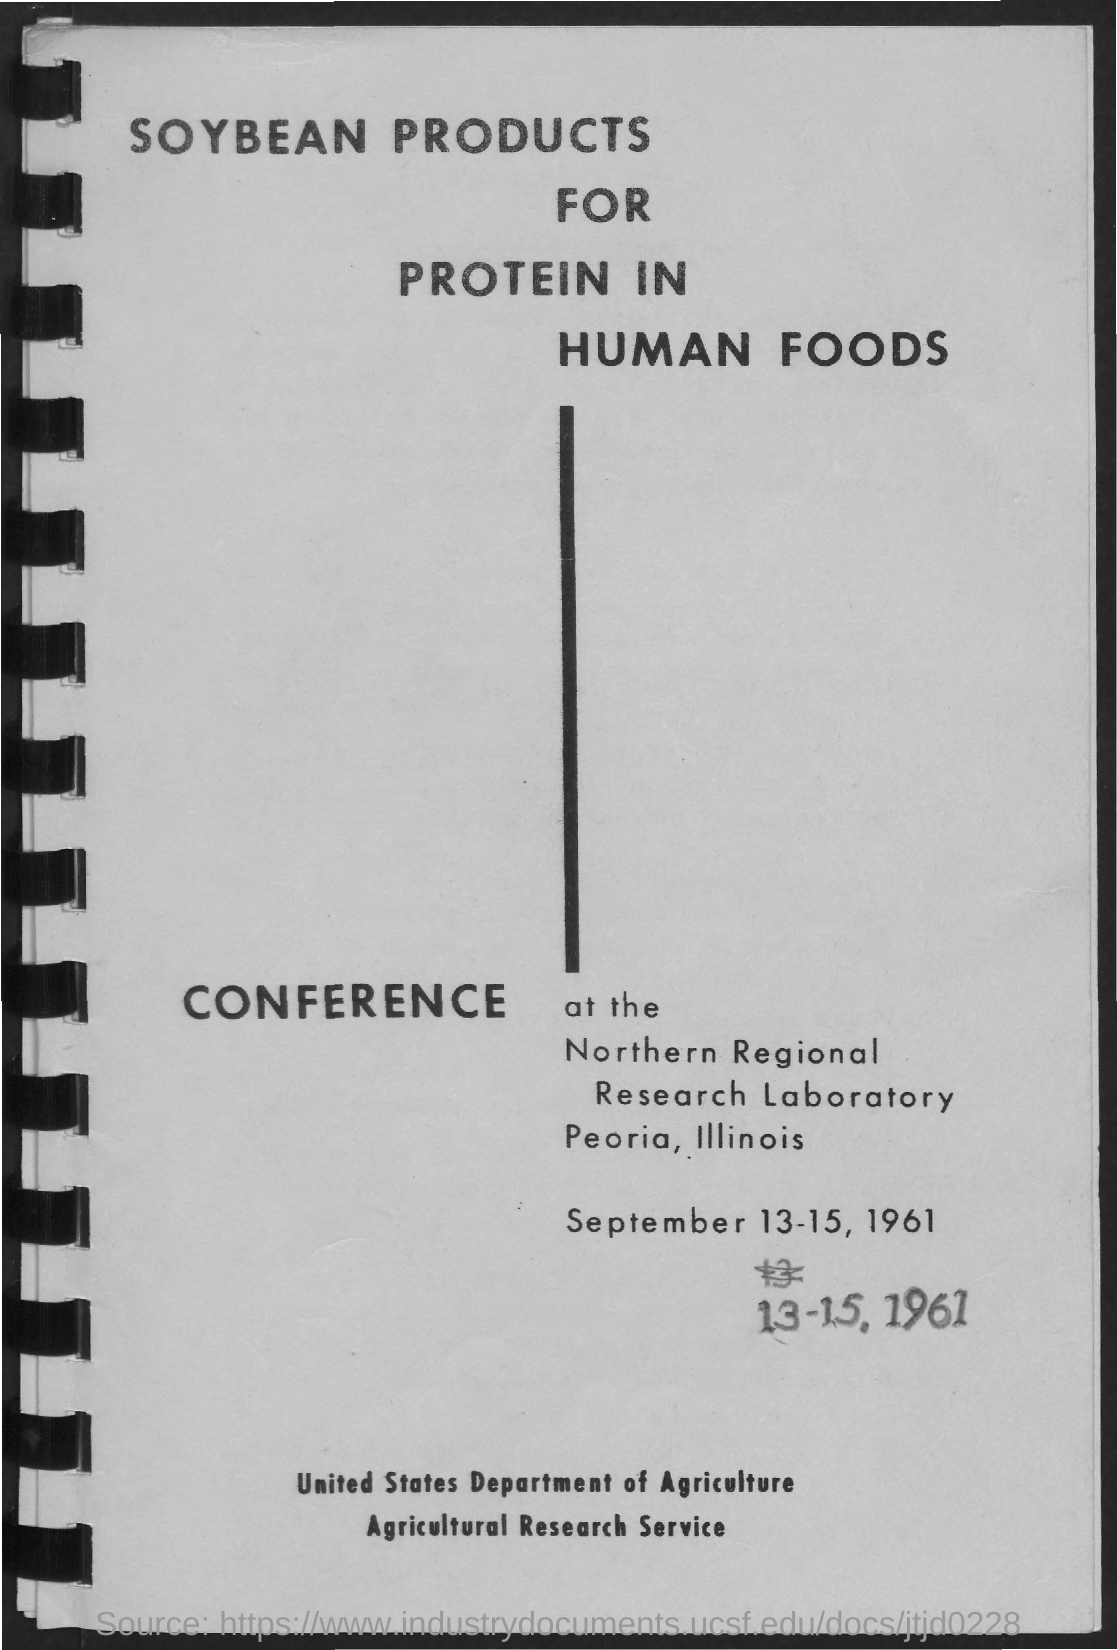When is the conference?
Give a very brief answer. September 13-15, 1961. Which city and state is it held in?
Keep it short and to the point. Peoria, illinois. 